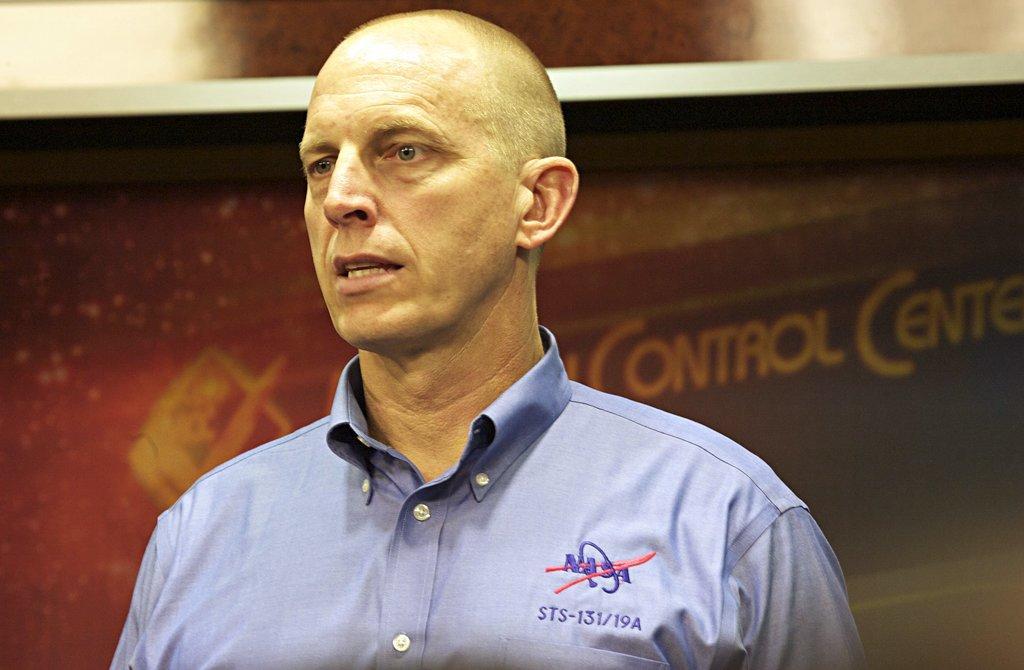Describe this image in one or two sentences. In this image in the center there is one person it seems that he is talking, and in the background there is text and there might be a board and wall and some object. 